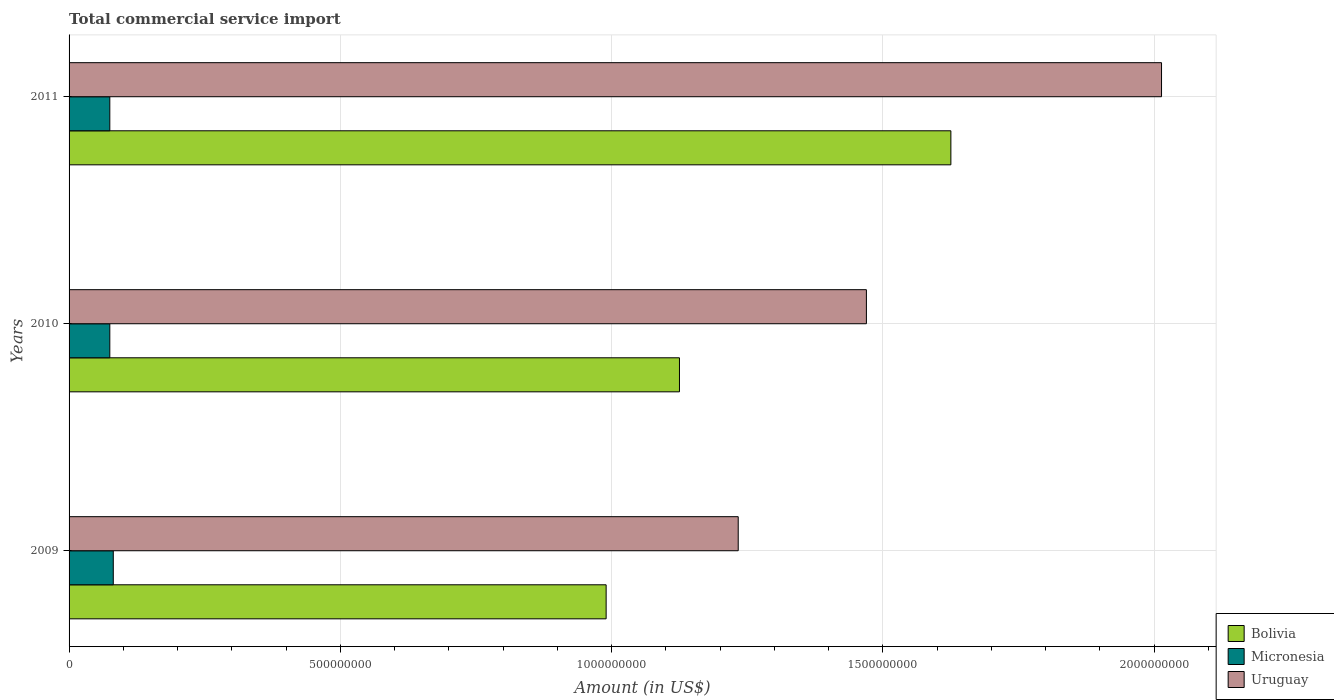How many different coloured bars are there?
Ensure brevity in your answer.  3. Are the number of bars per tick equal to the number of legend labels?
Provide a succinct answer. Yes. Are the number of bars on each tick of the Y-axis equal?
Give a very brief answer. Yes. How many bars are there on the 3rd tick from the top?
Your answer should be very brief. 3. How many bars are there on the 2nd tick from the bottom?
Your response must be concise. 3. What is the label of the 2nd group of bars from the top?
Your answer should be compact. 2010. What is the total commercial service import in Micronesia in 2009?
Ensure brevity in your answer.  8.15e+07. Across all years, what is the maximum total commercial service import in Micronesia?
Offer a terse response. 8.15e+07. Across all years, what is the minimum total commercial service import in Micronesia?
Offer a very short reply. 7.51e+07. In which year was the total commercial service import in Bolivia maximum?
Make the answer very short. 2011. In which year was the total commercial service import in Micronesia minimum?
Your answer should be very brief. 2011. What is the total total commercial service import in Uruguay in the graph?
Make the answer very short. 4.72e+09. What is the difference between the total commercial service import in Bolivia in 2010 and that in 2011?
Offer a very short reply. -5.00e+08. What is the difference between the total commercial service import in Uruguay in 2010 and the total commercial service import in Micronesia in 2011?
Your answer should be compact. 1.39e+09. What is the average total commercial service import in Uruguay per year?
Provide a succinct answer. 1.57e+09. In the year 2011, what is the difference between the total commercial service import in Bolivia and total commercial service import in Uruguay?
Ensure brevity in your answer.  -3.88e+08. In how many years, is the total commercial service import in Bolivia greater than 1400000000 US$?
Your answer should be very brief. 1. What is the ratio of the total commercial service import in Uruguay in 2009 to that in 2010?
Provide a short and direct response. 0.84. Is the total commercial service import in Bolivia in 2009 less than that in 2011?
Give a very brief answer. Yes. What is the difference between the highest and the second highest total commercial service import in Micronesia?
Your answer should be compact. 6.39e+06. What is the difference between the highest and the lowest total commercial service import in Uruguay?
Make the answer very short. 7.80e+08. In how many years, is the total commercial service import in Micronesia greater than the average total commercial service import in Micronesia taken over all years?
Your response must be concise. 1. Is the sum of the total commercial service import in Uruguay in 2009 and 2011 greater than the maximum total commercial service import in Bolivia across all years?
Offer a terse response. Yes. What does the 2nd bar from the bottom in 2011 represents?
Offer a terse response. Micronesia. How many bars are there?
Offer a terse response. 9. Are all the bars in the graph horizontal?
Your answer should be compact. Yes. How many years are there in the graph?
Offer a terse response. 3. Are the values on the major ticks of X-axis written in scientific E-notation?
Offer a terse response. No. How are the legend labels stacked?
Your answer should be compact. Vertical. What is the title of the graph?
Make the answer very short. Total commercial service import. Does "Europe(all income levels)" appear as one of the legend labels in the graph?
Offer a terse response. No. What is the label or title of the X-axis?
Keep it short and to the point. Amount (in US$). What is the Amount (in US$) in Bolivia in 2009?
Offer a very short reply. 9.90e+08. What is the Amount (in US$) in Micronesia in 2009?
Make the answer very short. 8.15e+07. What is the Amount (in US$) in Uruguay in 2009?
Your answer should be very brief. 1.23e+09. What is the Amount (in US$) in Bolivia in 2010?
Keep it short and to the point. 1.13e+09. What is the Amount (in US$) in Micronesia in 2010?
Offer a terse response. 7.51e+07. What is the Amount (in US$) of Uruguay in 2010?
Offer a very short reply. 1.47e+09. What is the Amount (in US$) of Bolivia in 2011?
Provide a short and direct response. 1.63e+09. What is the Amount (in US$) of Micronesia in 2011?
Make the answer very short. 7.51e+07. What is the Amount (in US$) of Uruguay in 2011?
Your response must be concise. 2.01e+09. Across all years, what is the maximum Amount (in US$) of Bolivia?
Provide a short and direct response. 1.63e+09. Across all years, what is the maximum Amount (in US$) of Micronesia?
Your response must be concise. 8.15e+07. Across all years, what is the maximum Amount (in US$) in Uruguay?
Your answer should be compact. 2.01e+09. Across all years, what is the minimum Amount (in US$) of Bolivia?
Your response must be concise. 9.90e+08. Across all years, what is the minimum Amount (in US$) of Micronesia?
Keep it short and to the point. 7.51e+07. Across all years, what is the minimum Amount (in US$) in Uruguay?
Offer a terse response. 1.23e+09. What is the total Amount (in US$) in Bolivia in the graph?
Keep it short and to the point. 3.74e+09. What is the total Amount (in US$) of Micronesia in the graph?
Provide a short and direct response. 2.32e+08. What is the total Amount (in US$) of Uruguay in the graph?
Provide a short and direct response. 4.72e+09. What is the difference between the Amount (in US$) in Bolivia in 2009 and that in 2010?
Ensure brevity in your answer.  -1.35e+08. What is the difference between the Amount (in US$) of Micronesia in 2009 and that in 2010?
Keep it short and to the point. 6.39e+06. What is the difference between the Amount (in US$) in Uruguay in 2009 and that in 2010?
Offer a terse response. -2.36e+08. What is the difference between the Amount (in US$) in Bolivia in 2009 and that in 2011?
Give a very brief answer. -6.35e+08. What is the difference between the Amount (in US$) in Micronesia in 2009 and that in 2011?
Ensure brevity in your answer.  6.40e+06. What is the difference between the Amount (in US$) in Uruguay in 2009 and that in 2011?
Offer a terse response. -7.80e+08. What is the difference between the Amount (in US$) in Bolivia in 2010 and that in 2011?
Provide a succinct answer. -5.00e+08. What is the difference between the Amount (in US$) in Micronesia in 2010 and that in 2011?
Give a very brief answer. 6825.13. What is the difference between the Amount (in US$) in Uruguay in 2010 and that in 2011?
Provide a succinct answer. -5.44e+08. What is the difference between the Amount (in US$) in Bolivia in 2009 and the Amount (in US$) in Micronesia in 2010?
Give a very brief answer. 9.15e+08. What is the difference between the Amount (in US$) in Bolivia in 2009 and the Amount (in US$) in Uruguay in 2010?
Provide a succinct answer. -4.80e+08. What is the difference between the Amount (in US$) of Micronesia in 2009 and the Amount (in US$) of Uruguay in 2010?
Keep it short and to the point. -1.39e+09. What is the difference between the Amount (in US$) of Bolivia in 2009 and the Amount (in US$) of Micronesia in 2011?
Your answer should be compact. 9.15e+08. What is the difference between the Amount (in US$) in Bolivia in 2009 and the Amount (in US$) in Uruguay in 2011?
Ensure brevity in your answer.  -1.02e+09. What is the difference between the Amount (in US$) of Micronesia in 2009 and the Amount (in US$) of Uruguay in 2011?
Your answer should be compact. -1.93e+09. What is the difference between the Amount (in US$) in Bolivia in 2010 and the Amount (in US$) in Micronesia in 2011?
Ensure brevity in your answer.  1.05e+09. What is the difference between the Amount (in US$) in Bolivia in 2010 and the Amount (in US$) in Uruguay in 2011?
Offer a very short reply. -8.88e+08. What is the difference between the Amount (in US$) in Micronesia in 2010 and the Amount (in US$) in Uruguay in 2011?
Your answer should be compact. -1.94e+09. What is the average Amount (in US$) in Bolivia per year?
Offer a terse response. 1.25e+09. What is the average Amount (in US$) in Micronesia per year?
Ensure brevity in your answer.  7.72e+07. What is the average Amount (in US$) in Uruguay per year?
Provide a short and direct response. 1.57e+09. In the year 2009, what is the difference between the Amount (in US$) in Bolivia and Amount (in US$) in Micronesia?
Your response must be concise. 9.08e+08. In the year 2009, what is the difference between the Amount (in US$) in Bolivia and Amount (in US$) in Uruguay?
Make the answer very short. -2.43e+08. In the year 2009, what is the difference between the Amount (in US$) of Micronesia and Amount (in US$) of Uruguay?
Offer a very short reply. -1.15e+09. In the year 2010, what is the difference between the Amount (in US$) in Bolivia and Amount (in US$) in Micronesia?
Offer a terse response. 1.05e+09. In the year 2010, what is the difference between the Amount (in US$) of Bolivia and Amount (in US$) of Uruguay?
Your answer should be very brief. -3.45e+08. In the year 2010, what is the difference between the Amount (in US$) of Micronesia and Amount (in US$) of Uruguay?
Your response must be concise. -1.39e+09. In the year 2011, what is the difference between the Amount (in US$) of Bolivia and Amount (in US$) of Micronesia?
Ensure brevity in your answer.  1.55e+09. In the year 2011, what is the difference between the Amount (in US$) in Bolivia and Amount (in US$) in Uruguay?
Your response must be concise. -3.88e+08. In the year 2011, what is the difference between the Amount (in US$) in Micronesia and Amount (in US$) in Uruguay?
Provide a short and direct response. -1.94e+09. What is the ratio of the Amount (in US$) of Bolivia in 2009 to that in 2010?
Provide a short and direct response. 0.88. What is the ratio of the Amount (in US$) in Micronesia in 2009 to that in 2010?
Offer a very short reply. 1.09. What is the ratio of the Amount (in US$) of Uruguay in 2009 to that in 2010?
Offer a very short reply. 0.84. What is the ratio of the Amount (in US$) in Bolivia in 2009 to that in 2011?
Offer a terse response. 0.61. What is the ratio of the Amount (in US$) of Micronesia in 2009 to that in 2011?
Keep it short and to the point. 1.09. What is the ratio of the Amount (in US$) in Uruguay in 2009 to that in 2011?
Your answer should be very brief. 0.61. What is the ratio of the Amount (in US$) in Bolivia in 2010 to that in 2011?
Make the answer very short. 0.69. What is the ratio of the Amount (in US$) in Micronesia in 2010 to that in 2011?
Provide a short and direct response. 1. What is the ratio of the Amount (in US$) in Uruguay in 2010 to that in 2011?
Offer a terse response. 0.73. What is the difference between the highest and the second highest Amount (in US$) of Bolivia?
Provide a short and direct response. 5.00e+08. What is the difference between the highest and the second highest Amount (in US$) of Micronesia?
Give a very brief answer. 6.39e+06. What is the difference between the highest and the second highest Amount (in US$) in Uruguay?
Provide a succinct answer. 5.44e+08. What is the difference between the highest and the lowest Amount (in US$) in Bolivia?
Make the answer very short. 6.35e+08. What is the difference between the highest and the lowest Amount (in US$) in Micronesia?
Your response must be concise. 6.40e+06. What is the difference between the highest and the lowest Amount (in US$) in Uruguay?
Offer a very short reply. 7.80e+08. 